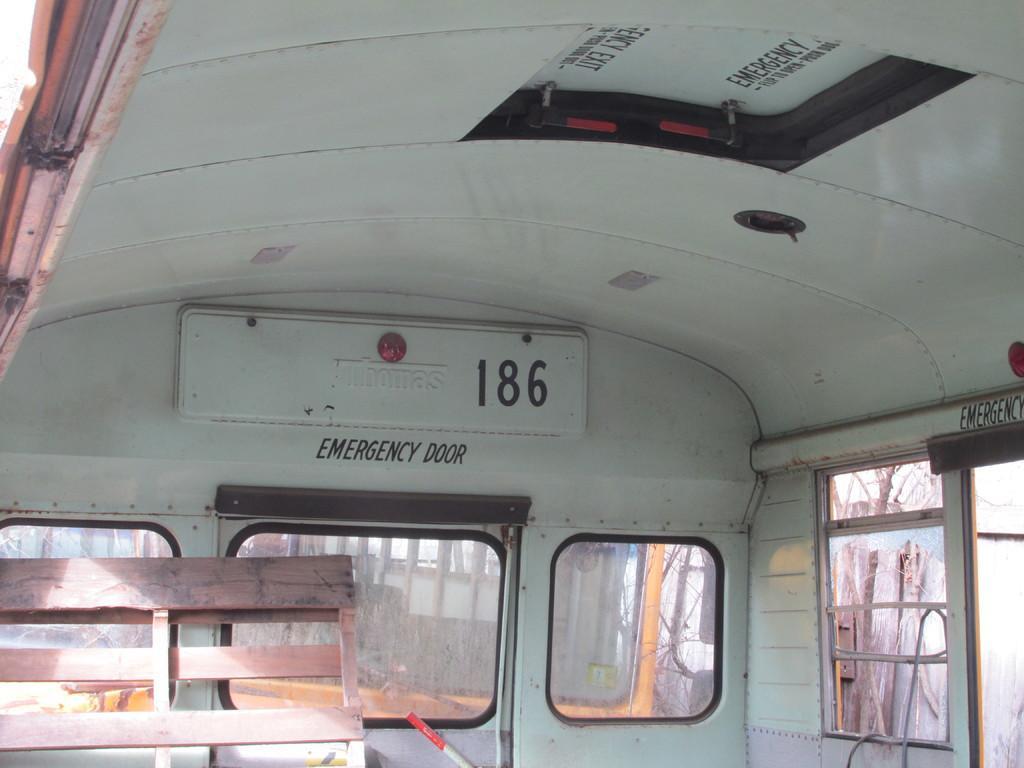How would you summarize this image in a sentence or two? This image is taken in inside the vehicle. In this image there is a wooden structure and a rod, there are few glass windows through which we can see there are trees. 